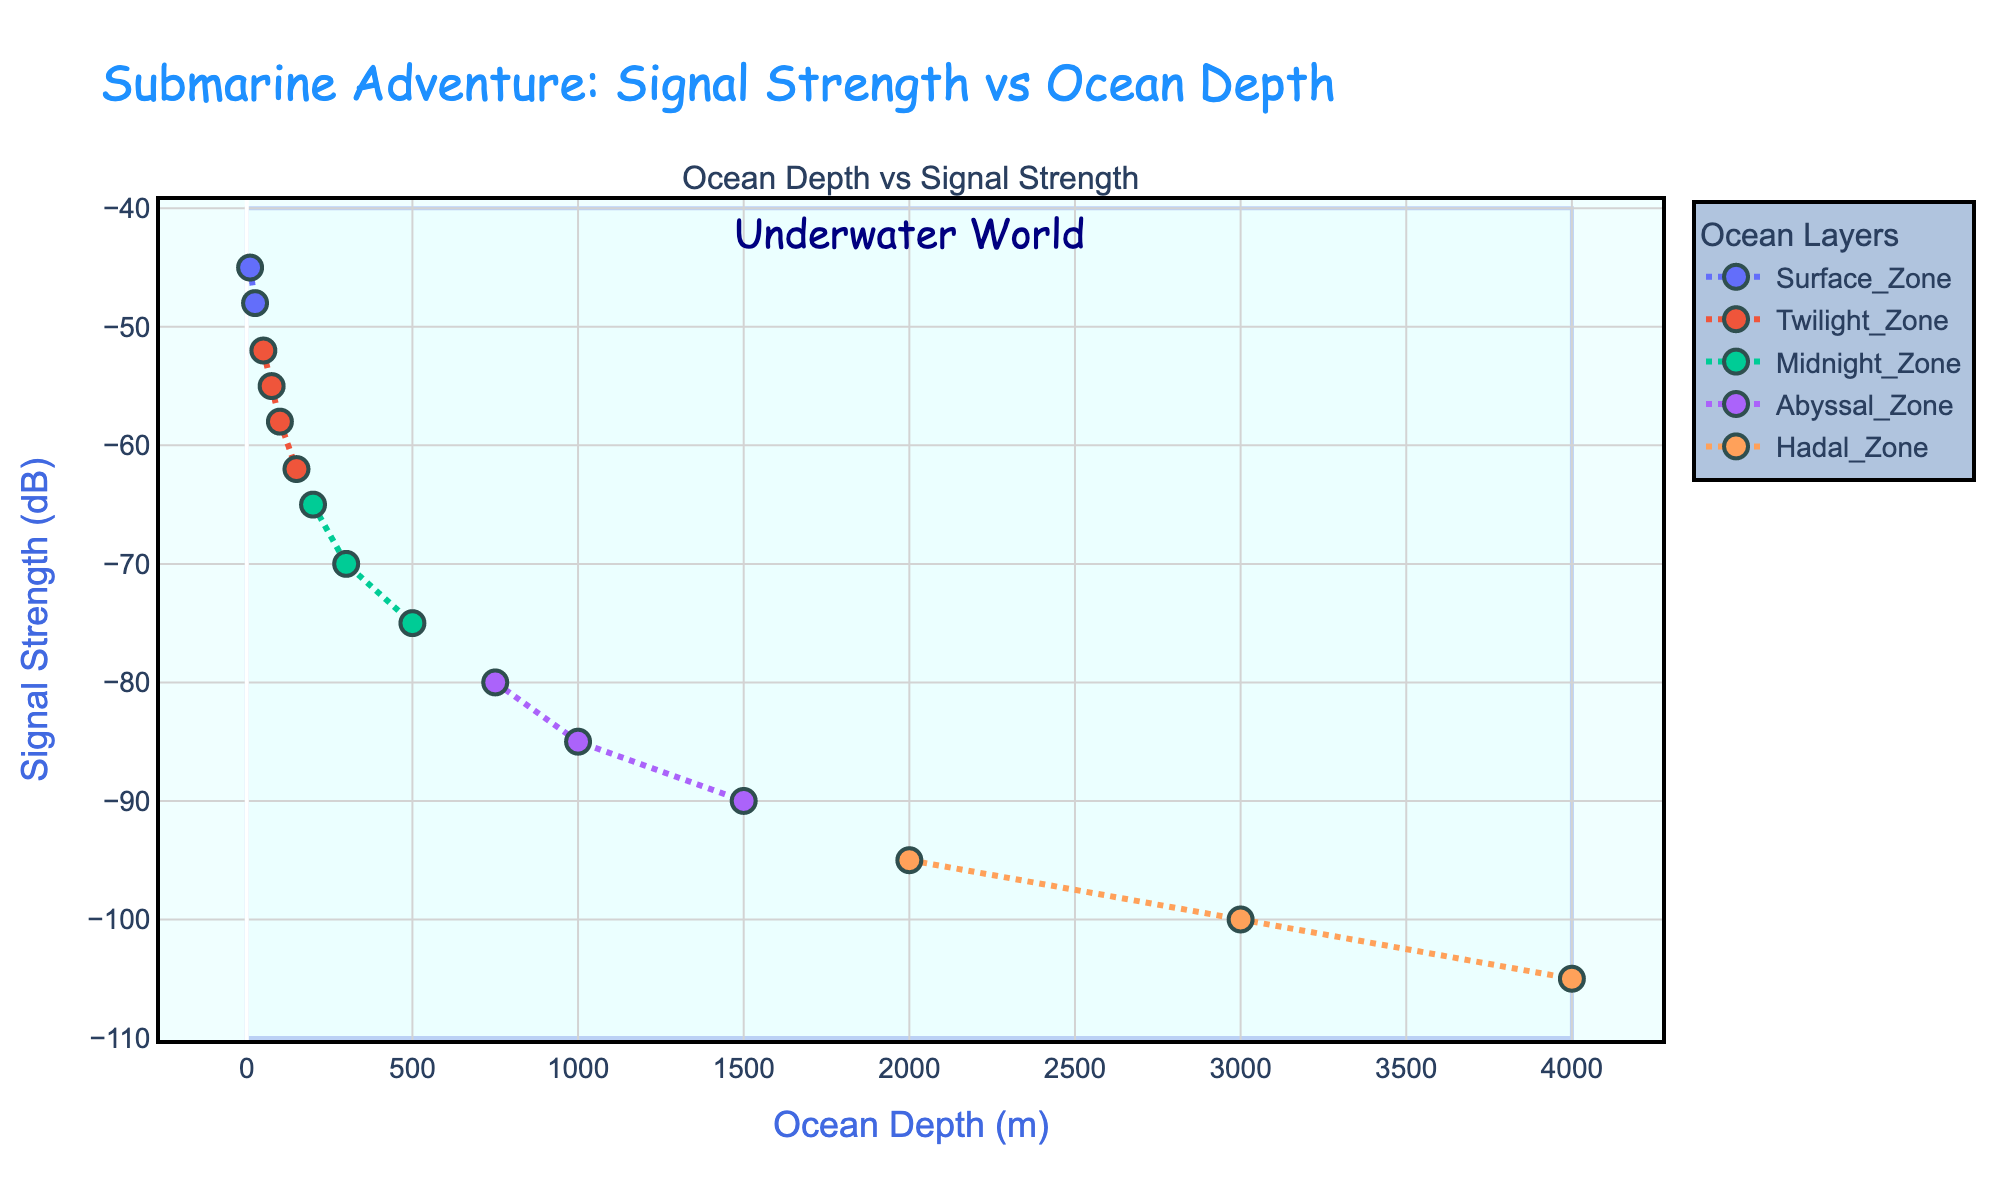What is the title of the plot? The title is found at the top of the plot. It is usually larger and more prominent than other text.
Answer: Submarine Adventure: Signal Strength vs Ocean Depth What does the x-axis represent? The x-axis is labeled at the bottom of the plot, where it indicates what is measured along this axis.
Answer: Ocean Depth (m) How many ocean layers are categorized in the plot? Count the unique legend entries, which represent different ocean layers.
Answer: Five What depth range is covered in this plot? Check the lowest and highest values on the x-axis to determine the range.
Answer: 0 to 4000 meters At what ocean depth is the signal strength -100 dB? Identify the point on the plot where the y-axis value reaches -100 dB, then trace it back to the corresponding x-axis value.
Answer: 3000 meters What is the signal strength at 500 meters depth? Locate the data point corresponding to 500 meters on the x-axis and read off the y-axis value.
Answer: -75 dB Which ocean layer shows the steepest decrease in signal strength? Compare the slopes of the lines for each ocean layer; the steeper the line, the more rapid the decrease.
Answer: Midnight Zone How does the signal strength change as the depth increases? Observe the overall trend of the data points from left (shallow) to right (deep).
Answer: It decreases In which layer does the signal strength vary the least? Look at the range of y-axis values within each ocean layer to determine which one has the smallest variation.
Answer: Hadal Zone Which ocean layer has the deepest starting point based on the plot? Check the x-axis values where the first data point of each ocean layer begins.
Answer: Abyssal Zone 